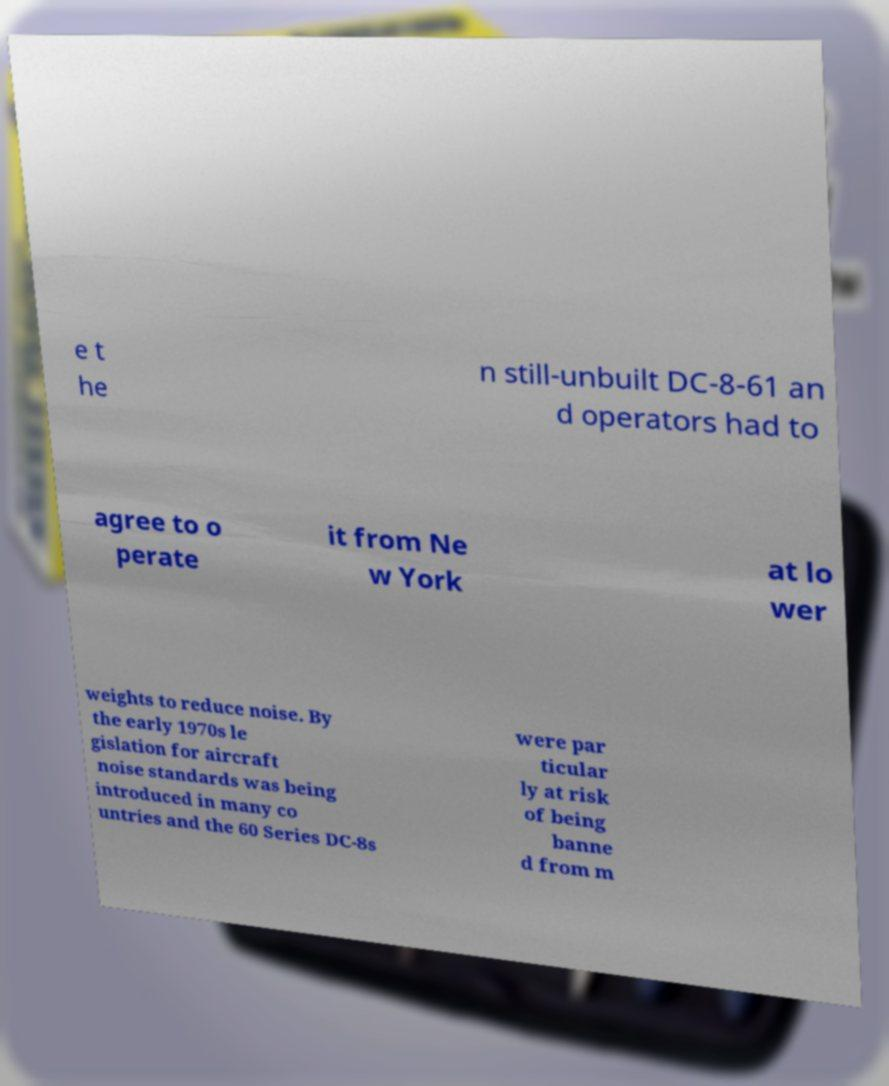Can you read and provide the text displayed in the image?This photo seems to have some interesting text. Can you extract and type it out for me? e t he n still-unbuilt DC-8-61 an d operators had to agree to o perate it from Ne w York at lo wer weights to reduce noise. By the early 1970s le gislation for aircraft noise standards was being introduced in many co untries and the 60 Series DC-8s were par ticular ly at risk of being banne d from m 